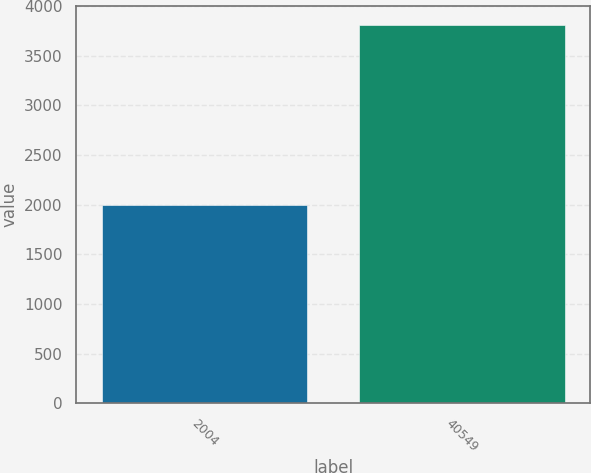Convert chart. <chart><loc_0><loc_0><loc_500><loc_500><bar_chart><fcel>2004<fcel>40549<nl><fcel>2001<fcel>3812<nl></chart> 